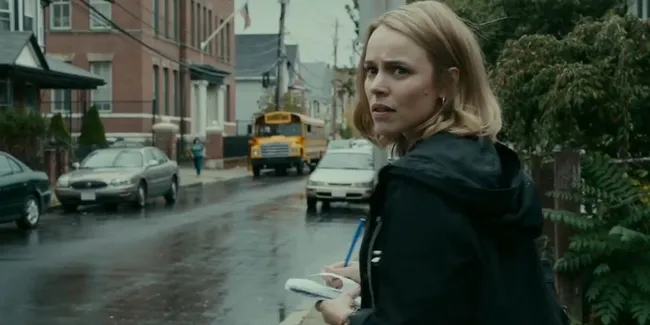Can you tell me more about the setting of this scene? The scene is set on a rainy, urban street. The buildings lining the street are made of red brick, with some greenery visible on the right side of the frame. Parked cars and a distinctive yellow school bus add to the atmosphere of a typical city neighborhood. The wet pavement and overcast sky suggest a dreary, possibly tense moment, and the woman’s concerned expression further builds on this mood. What might the presence of the yellow school bus indicate? The yellow school bus could indicate several things. It might suggest that this scene takes place near a school or during school hours when buses are typically in operation. The presence of the bus also adds to the urban, everyday setting of the scene, grounding it in a relatable reality. It could also imply that children or teenagers might be nearby or involved in the story in some way, adding to the complexity of the narrative or the tension of the moment. 